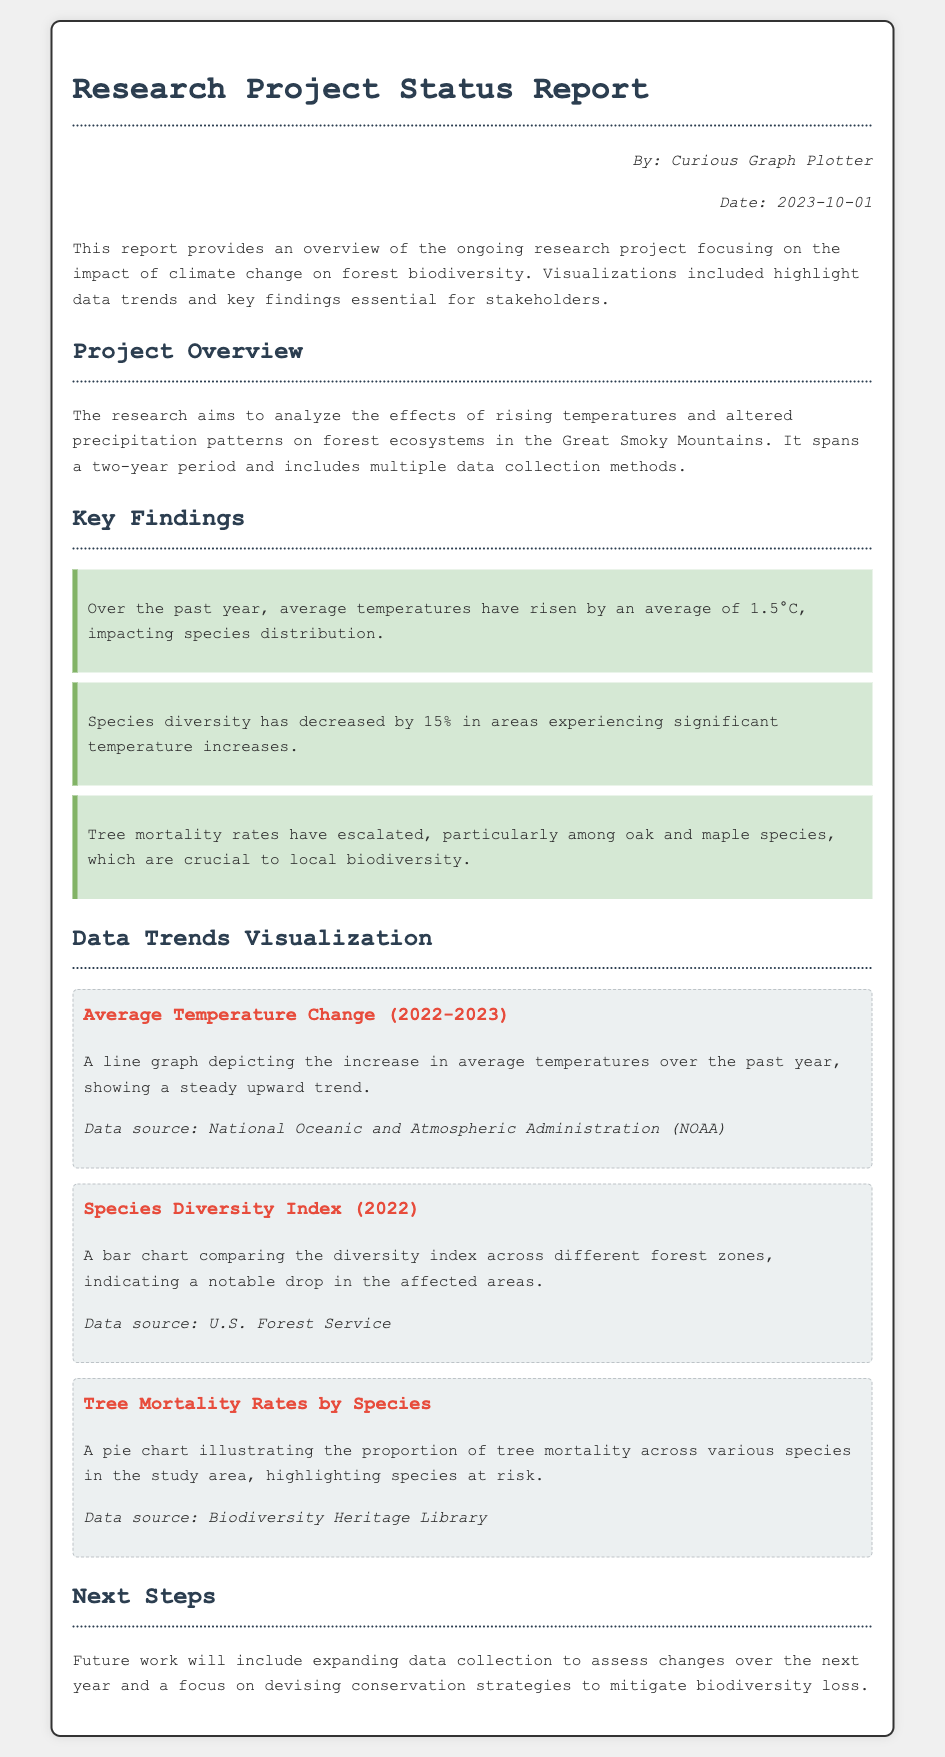What is the average temperature increase over the past year? The document states that average temperatures have risen by an average of 1.5°C.
Answer: 1.5°C What is the percentage decrease in species diversity? The report mentions that species diversity has decreased by 15% in affected areas.
Answer: 15% What year is the focus of the Species Diversity Index chart? The document indicates that the Species Diversity Index data is from 2022.
Answer: 2022 Which tree species are highlighted as experiencing increased mortality rates? The report specifically mentions oak and maple species in relation to tree mortality rates.
Answer: oak and maple Who is the author of the report? The document lists "Curious Graph Plotter" as the author.
Answer: Curious Graph Plotter What is the title of the graph depicting average temperature change? The title of the graph is "Average Temperature Change (2022-2023)".
Answer: Average Temperature Change (2022-2023) What data source is cited for the average temperature change graph? The source for the average temperature change graph is the National Oceanic and Atmospheric Administration (NOAA).
Answer: National Oceanic and Atmospheric Administration (NOAA) What is the goal of the future work mentioned in the report? The document states that future work will focus on assessing changes and devising conservation strategies.
Answer: conservation strategies 